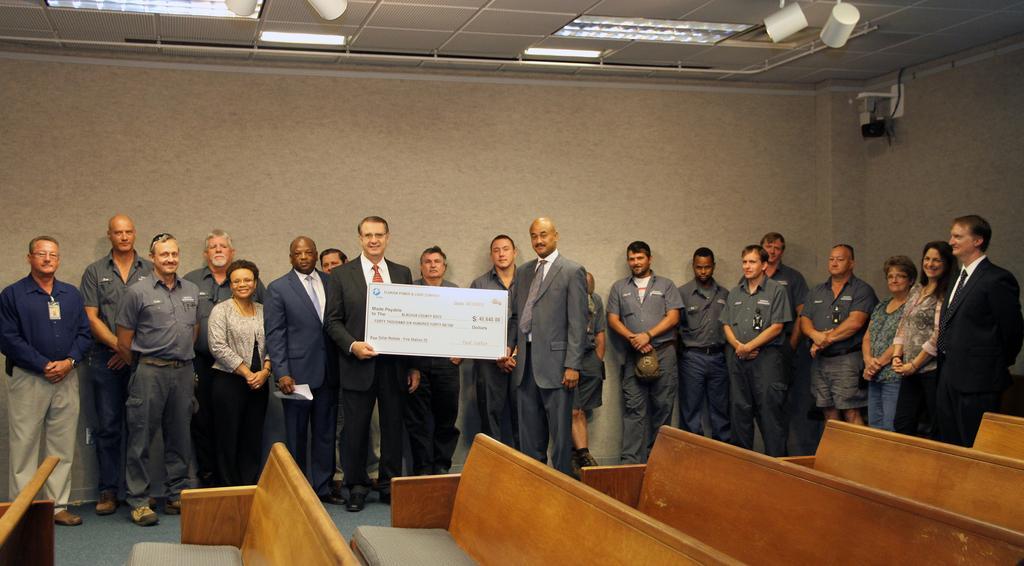Could you give a brief overview of what you see in this image? In this image in the center there are a group of people who are standing and one person is holding one board, and in the background there is a wall. On the top there is ceiling and some lights, at the bottom there are some benches. 